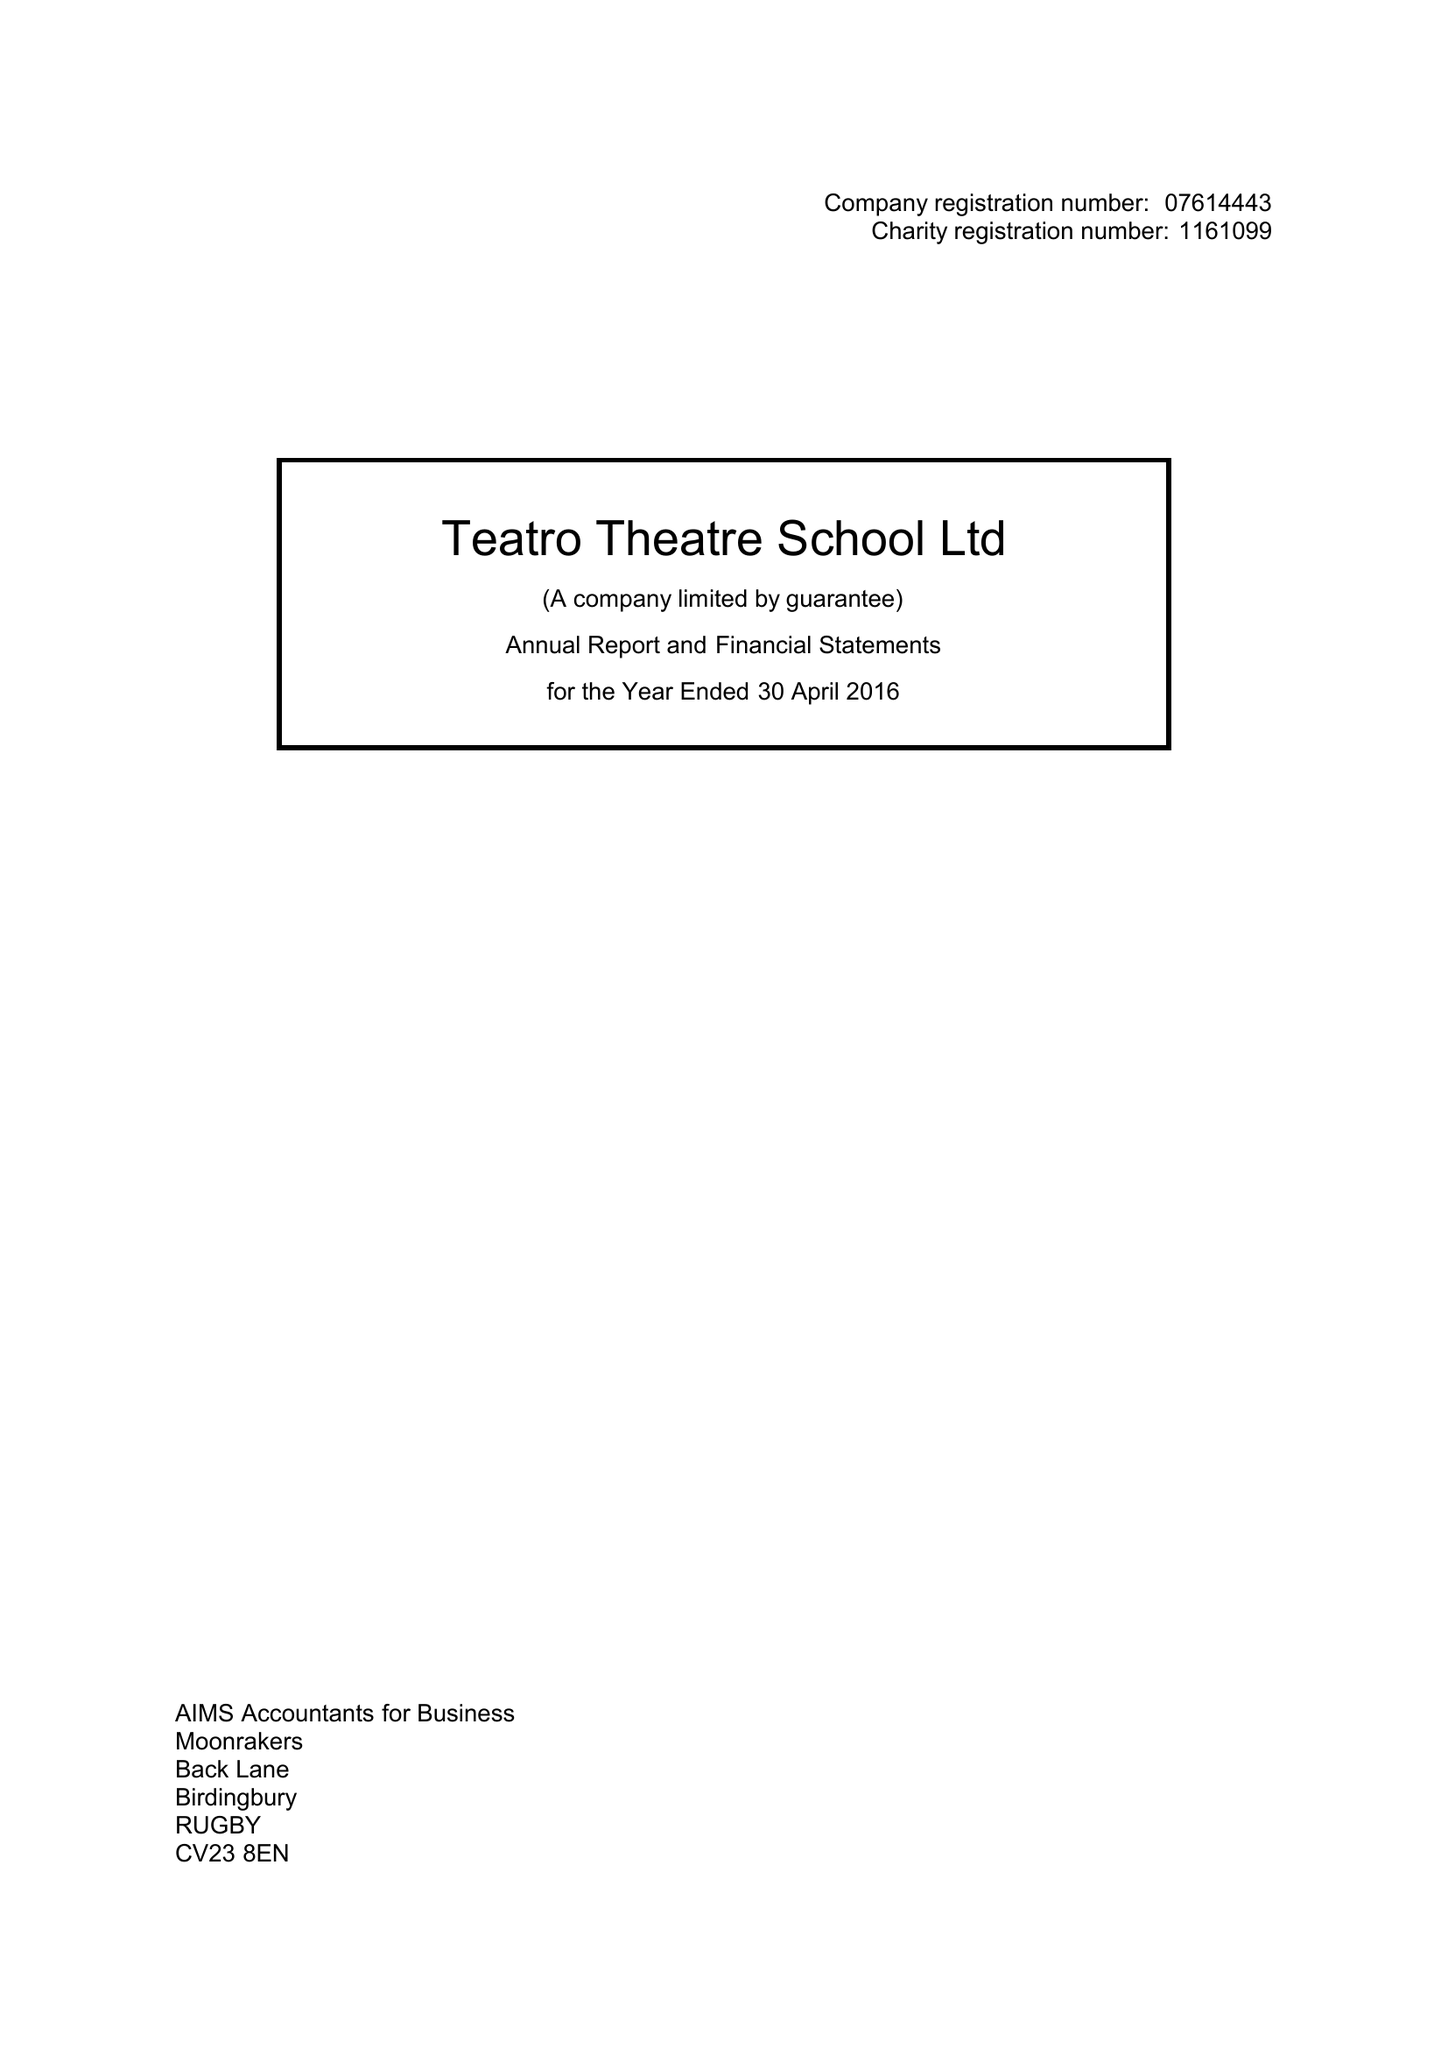What is the value for the charity_number?
Answer the question using a single word or phrase. 1161099 